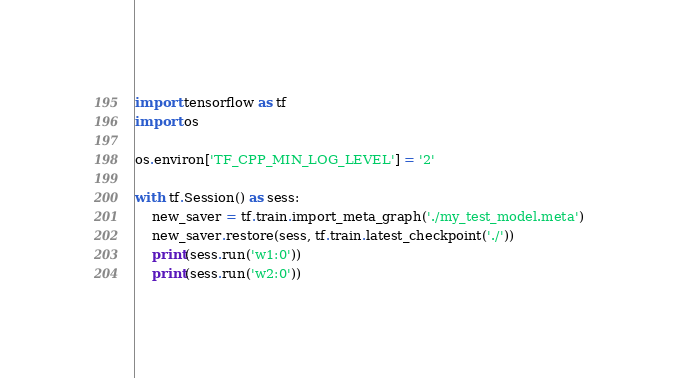<code> <loc_0><loc_0><loc_500><loc_500><_Python_>import tensorflow as tf
import os

os.environ['TF_CPP_MIN_LOG_LEVEL'] = '2'

with tf.Session() as sess:
    new_saver = tf.train.import_meta_graph('./my_test_model.meta')
    new_saver.restore(sess, tf.train.latest_checkpoint('./'))
    print(sess.run('w1:0'))
    print(sess.run('w2:0'))</code> 